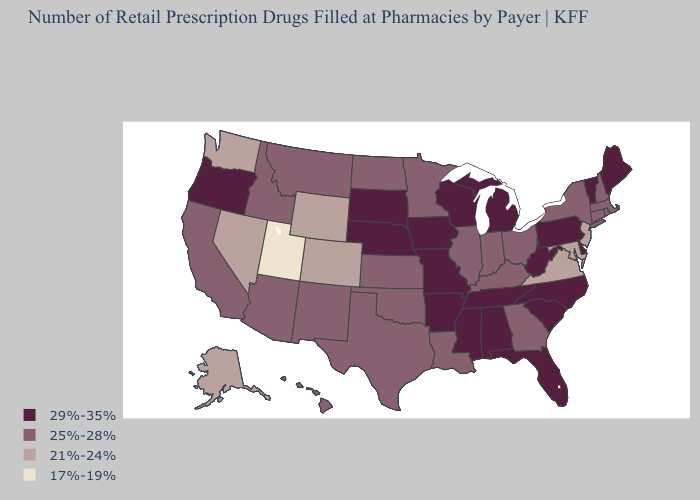What is the highest value in the South ?
Short answer required. 29%-35%. Does New Jersey have the lowest value in the Northeast?
Quick response, please. Yes. Is the legend a continuous bar?
Answer briefly. No. What is the highest value in states that border Vermont?
Write a very short answer. 25%-28%. Is the legend a continuous bar?
Keep it brief. No. Among the states that border Mississippi , which have the highest value?
Answer briefly. Alabama, Arkansas, Tennessee. What is the value of Illinois?
Keep it brief. 25%-28%. Does Wisconsin have the highest value in the MidWest?
Write a very short answer. Yes. What is the value of Pennsylvania?
Short answer required. 29%-35%. Does the map have missing data?
Give a very brief answer. No. Which states have the lowest value in the USA?
Keep it brief. Utah. Name the states that have a value in the range 25%-28%?
Give a very brief answer. Arizona, California, Connecticut, Georgia, Hawaii, Idaho, Illinois, Indiana, Kansas, Kentucky, Louisiana, Massachusetts, Minnesota, Montana, New Hampshire, New Mexico, New York, North Dakota, Ohio, Oklahoma, Rhode Island, Texas. Name the states that have a value in the range 25%-28%?
Give a very brief answer. Arizona, California, Connecticut, Georgia, Hawaii, Idaho, Illinois, Indiana, Kansas, Kentucky, Louisiana, Massachusetts, Minnesota, Montana, New Hampshire, New Mexico, New York, North Dakota, Ohio, Oklahoma, Rhode Island, Texas. How many symbols are there in the legend?
Keep it brief. 4. What is the lowest value in the West?
Concise answer only. 17%-19%. 